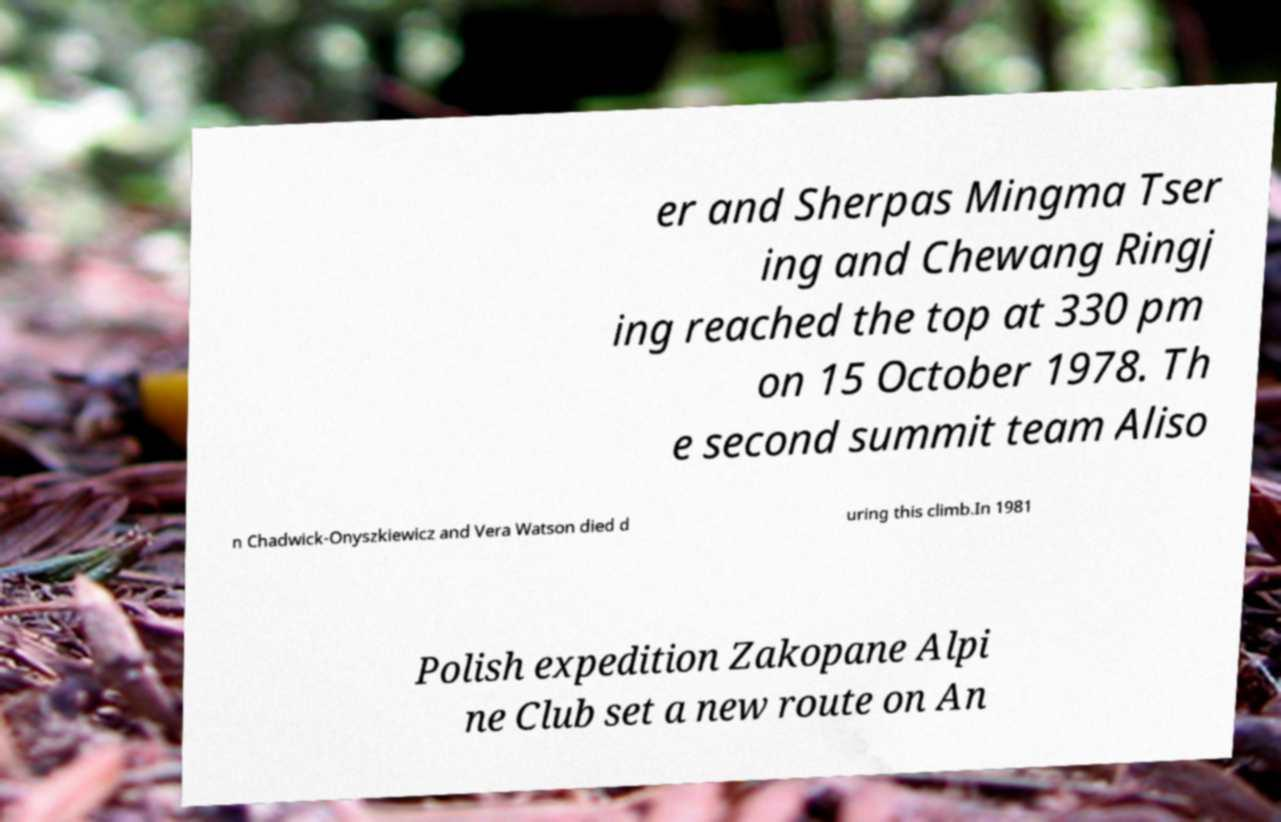I need the written content from this picture converted into text. Can you do that? er and Sherpas Mingma Tser ing and Chewang Ringj ing reached the top at 330 pm on 15 October 1978. Th e second summit team Aliso n Chadwick-Onyszkiewicz and Vera Watson died d uring this climb.In 1981 Polish expedition Zakopane Alpi ne Club set a new route on An 